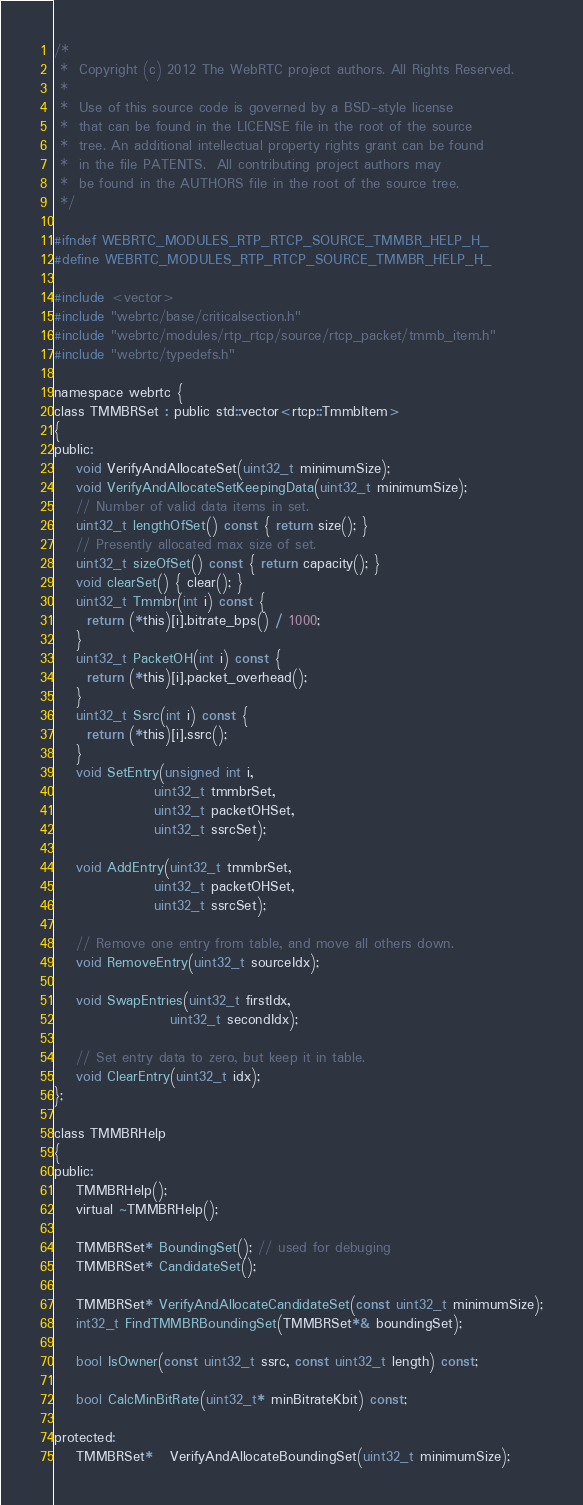Convert code to text. <code><loc_0><loc_0><loc_500><loc_500><_C_>/*
 *  Copyright (c) 2012 The WebRTC project authors. All Rights Reserved.
 *
 *  Use of this source code is governed by a BSD-style license
 *  that can be found in the LICENSE file in the root of the source
 *  tree. An additional intellectual property rights grant can be found
 *  in the file PATENTS.  All contributing project authors may
 *  be found in the AUTHORS file in the root of the source tree.
 */

#ifndef WEBRTC_MODULES_RTP_RTCP_SOURCE_TMMBR_HELP_H_
#define WEBRTC_MODULES_RTP_RTCP_SOURCE_TMMBR_HELP_H_

#include <vector>
#include "webrtc/base/criticalsection.h"
#include "webrtc/modules/rtp_rtcp/source/rtcp_packet/tmmb_item.h"
#include "webrtc/typedefs.h"

namespace webrtc {
class TMMBRSet : public std::vector<rtcp::TmmbItem>
{
public:
    void VerifyAndAllocateSet(uint32_t minimumSize);
    void VerifyAndAllocateSetKeepingData(uint32_t minimumSize);
    // Number of valid data items in set.
    uint32_t lengthOfSet() const { return size(); }
    // Presently allocated max size of set.
    uint32_t sizeOfSet() const { return capacity(); }
    void clearSet() { clear(); }
    uint32_t Tmmbr(int i) const {
      return (*this)[i].bitrate_bps() / 1000;
    }
    uint32_t PacketOH(int i) const {
      return (*this)[i].packet_overhead();
    }
    uint32_t Ssrc(int i) const {
      return (*this)[i].ssrc();
    }
    void SetEntry(unsigned int i,
                  uint32_t tmmbrSet,
                  uint32_t packetOHSet,
                  uint32_t ssrcSet);

    void AddEntry(uint32_t tmmbrSet,
                  uint32_t packetOHSet,
                  uint32_t ssrcSet);

    // Remove one entry from table, and move all others down.
    void RemoveEntry(uint32_t sourceIdx);

    void SwapEntries(uint32_t firstIdx,
                     uint32_t secondIdx);

    // Set entry data to zero, but keep it in table.
    void ClearEntry(uint32_t idx);
};

class TMMBRHelp
{
public:
    TMMBRHelp();
    virtual ~TMMBRHelp();

    TMMBRSet* BoundingSet(); // used for debuging
    TMMBRSet* CandidateSet();

    TMMBRSet* VerifyAndAllocateCandidateSet(const uint32_t minimumSize);
    int32_t FindTMMBRBoundingSet(TMMBRSet*& boundingSet);

    bool IsOwner(const uint32_t ssrc, const uint32_t length) const;

    bool CalcMinBitRate(uint32_t* minBitrateKbit) const;

protected:
    TMMBRSet*   VerifyAndAllocateBoundingSet(uint32_t minimumSize);</code> 